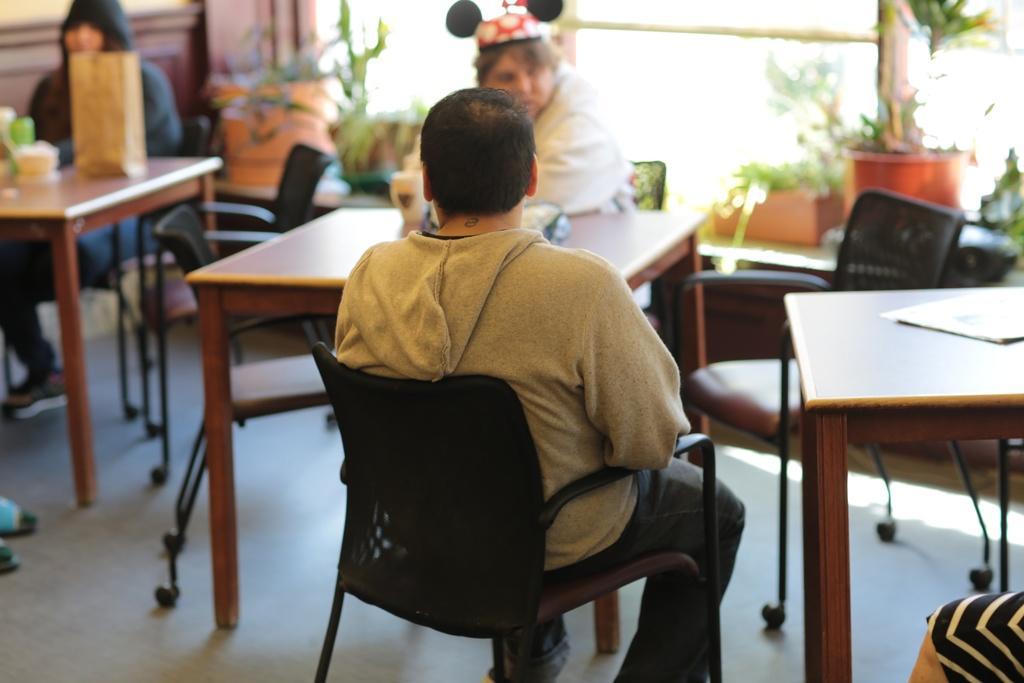In one or two sentences, can you explain what this image depicts? There are three persons sitting on chairs and we can see some objects on tables and we can see chairs and floor. On the background we can see house plants. 